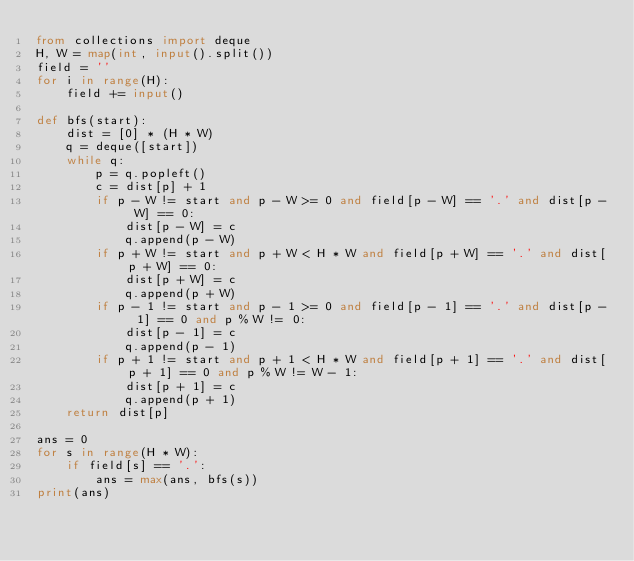Convert code to text. <code><loc_0><loc_0><loc_500><loc_500><_Python_>from collections import deque
H, W = map(int, input().split())
field = ''
for i in range(H):
    field += input()

def bfs(start):
    dist = [0] * (H * W)
    q = deque([start])
    while q:
        p = q.popleft()
        c = dist[p] + 1
        if p - W != start and p - W >= 0 and field[p - W] == '.' and dist[p - W] == 0:
            dist[p - W] = c
            q.append(p - W)
        if p + W != start and p + W < H * W and field[p + W] == '.' and dist[p + W] == 0:
            dist[p + W] = c
            q.append(p + W)
        if p - 1 != start and p - 1 >= 0 and field[p - 1] == '.' and dist[p - 1] == 0 and p % W != 0:
            dist[p - 1] = c
            q.append(p - 1)
        if p + 1 != start and p + 1 < H * W and field[p + 1] == '.' and dist[p + 1] == 0 and p % W != W - 1:
            dist[p + 1] = c
            q.append(p + 1)
    return dist[p]

ans = 0
for s in range(H * W):
    if field[s] == '.':
        ans = max(ans, bfs(s))
print(ans)
</code> 